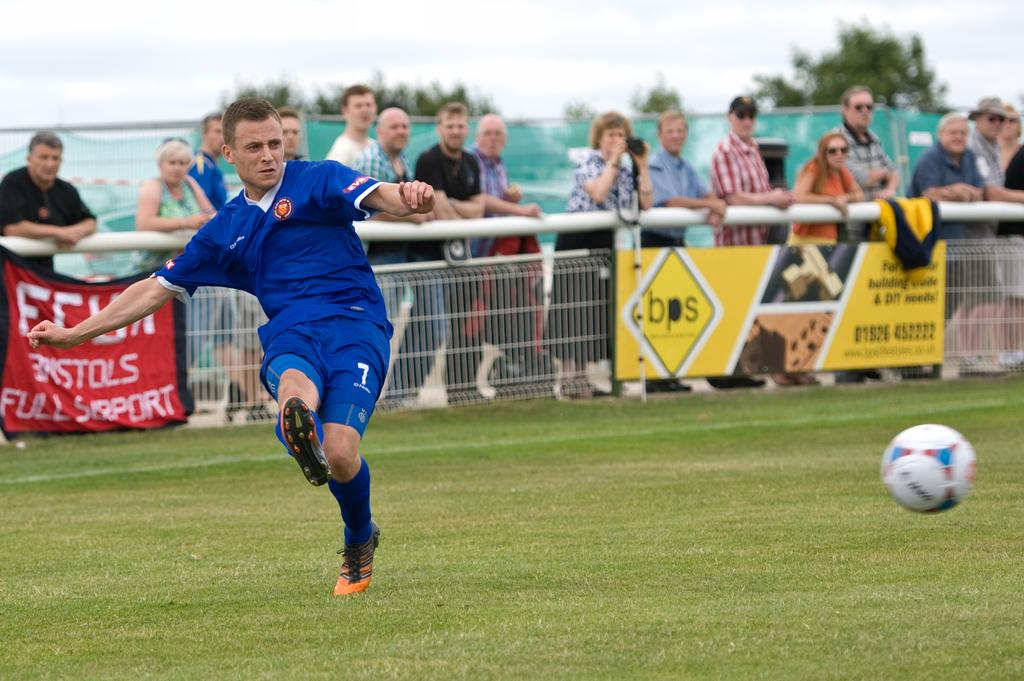<image>
Create a compact narrative representing the image presented. Soccer player number 7 has just kicked the ball and has his arms out. 